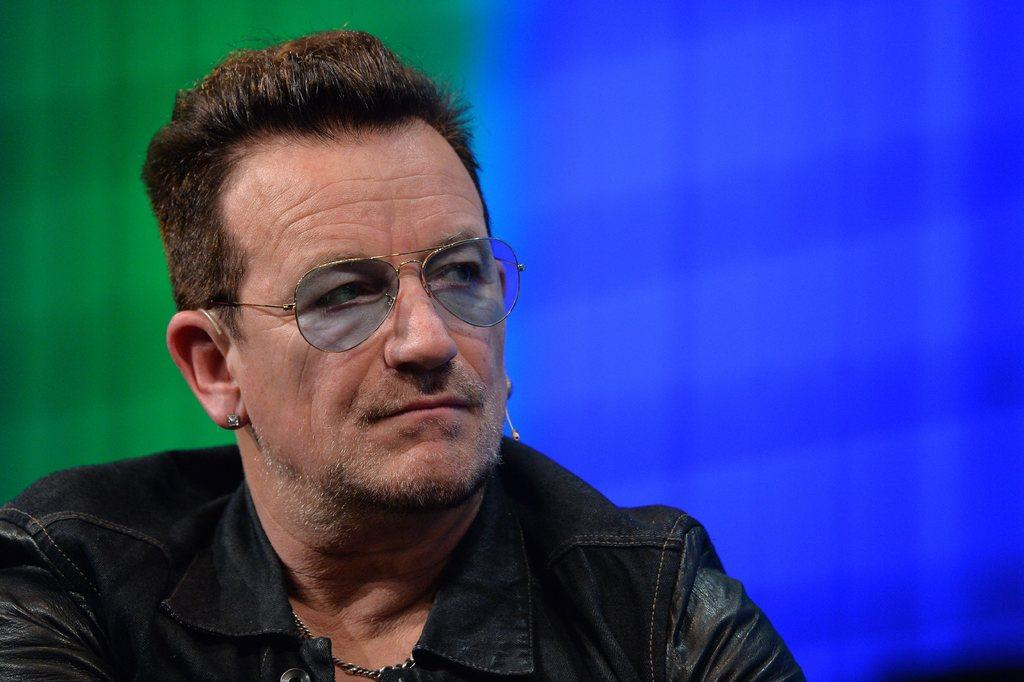What is the main subject in the foreground of the picture? There is a man in the foreground of the picture. What is the man wearing in the picture? The man is wearing a black jacket and spectacles. What can be seen in the background of the picture? There is a blue and green curtain in the background of the picture. What type of arithmetic problem is the man solving in the picture? There is no arithmetic problem visible in the picture, and the man's actions are not described. What is the source of power for the bells in the picture? There are no bells present in the picture, so it is not possible to determine the source of power for them. 